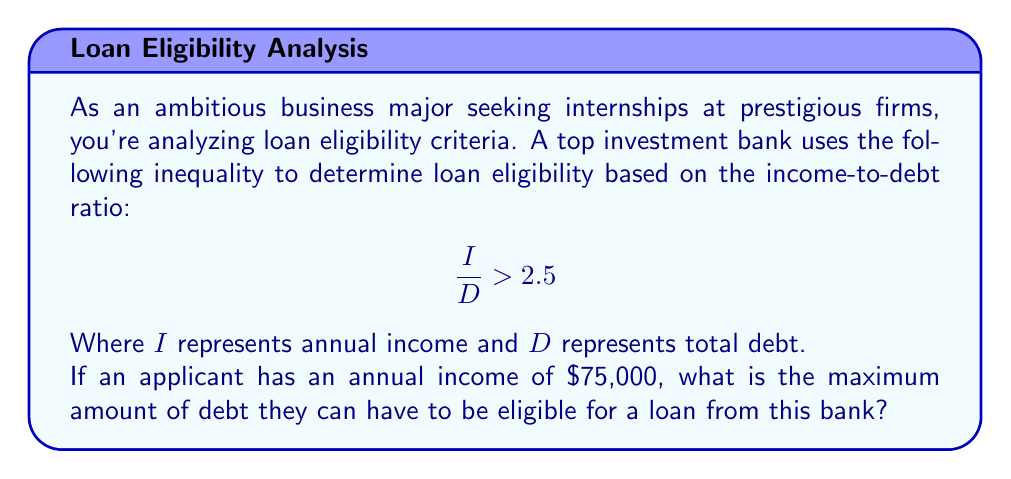Give your solution to this math problem. To solve this problem, we need to work with the given inequality:

$$\frac{I}{D} > 2.5$$

We know that $I = 75,000$, and we need to find the maximum value of $D$ that satisfies the inequality.

1. Substitute the known value:

   $$\frac{75,000}{D} > 2.5$$

2. To find the maximum debt, we need to consider the boundary case where the ratio equals 2.5:

   $$\frac{75,000}{D} = 2.5$$

3. Multiply both sides by $D$:

   $$75,000 = 2.5D$$

4. Divide both sides by 2.5:

   $$\frac{75,000}{2.5} = D$$

5. Calculate the result:

   $$30,000 = D$$

Therefore, the maximum amount of debt the applicant can have is $30,000. Any debt amount higher than this would result in an income-to-debt ratio lower than 2.5, making the applicant ineligible for the loan.
Answer: $30,000 